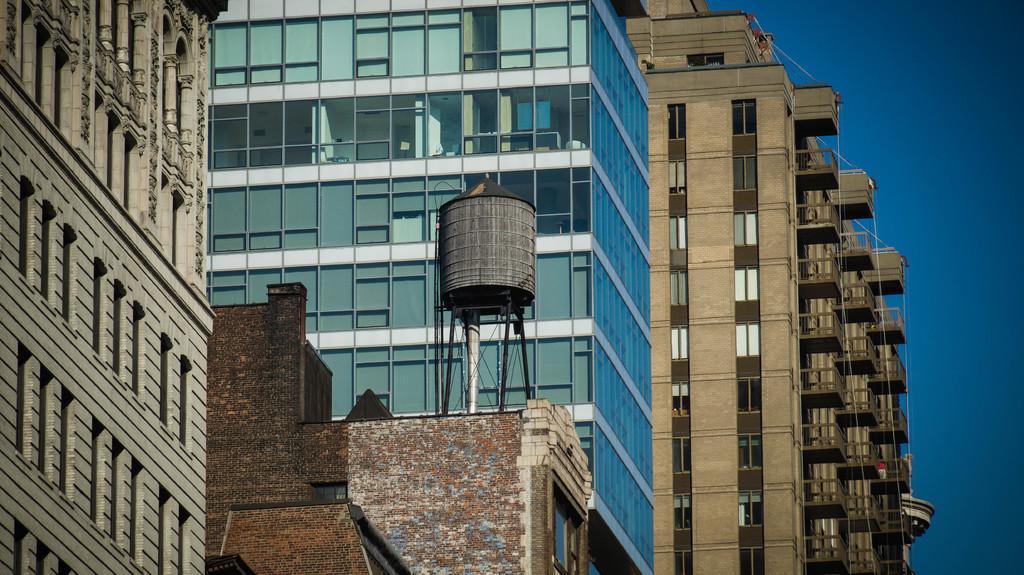Describe this image in one or two sentences. In this image, there are a few buildings. Among them, we can see a metallic object on one of the buildings. We can also see the sky. 